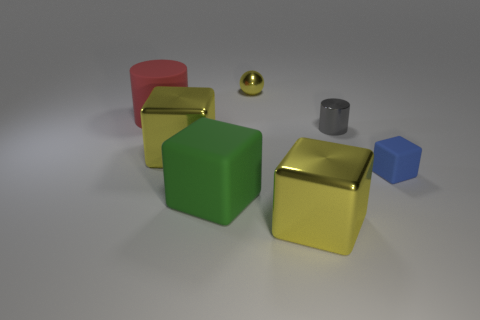What might be the texture of the objects? Based on the reflections and shine, the textures of the objects appear smooth and perhaps metallic or plastic. The level of shininess varies, with the gold blocks and the tiny ball reflecting the most light, indicating a highly polished surface. 